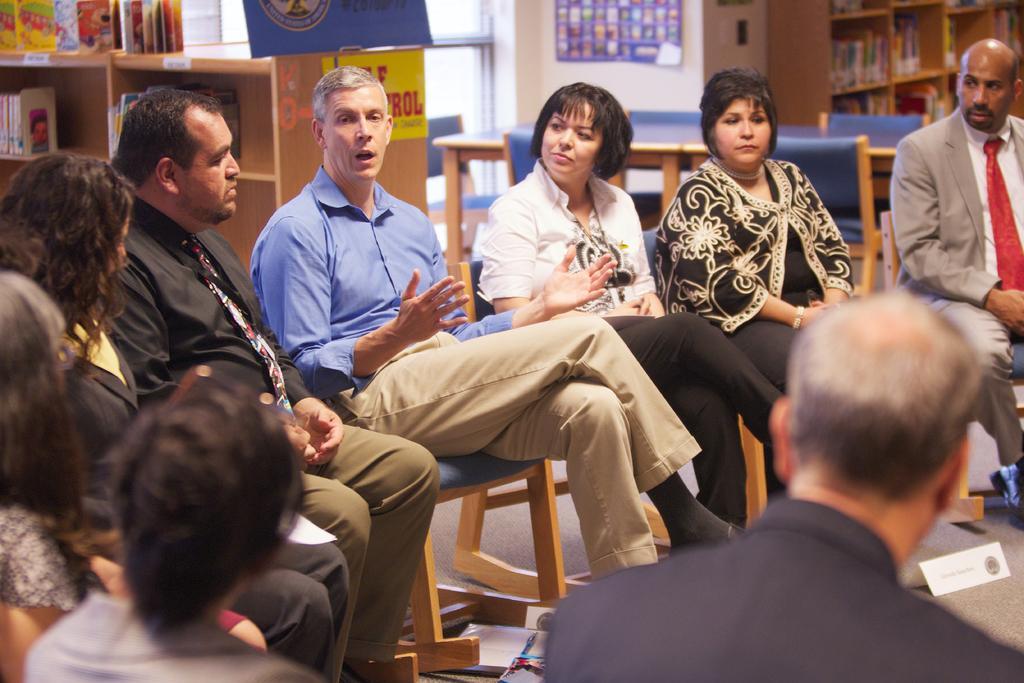How would you summarize this image in a sentence or two? In the picture we can see some people are sitting on the chairs and discussing something and one man is explaining to them, in the background we can find some racks of the wooden and table and some chairs and in the racks we can see books and wall near to it. 